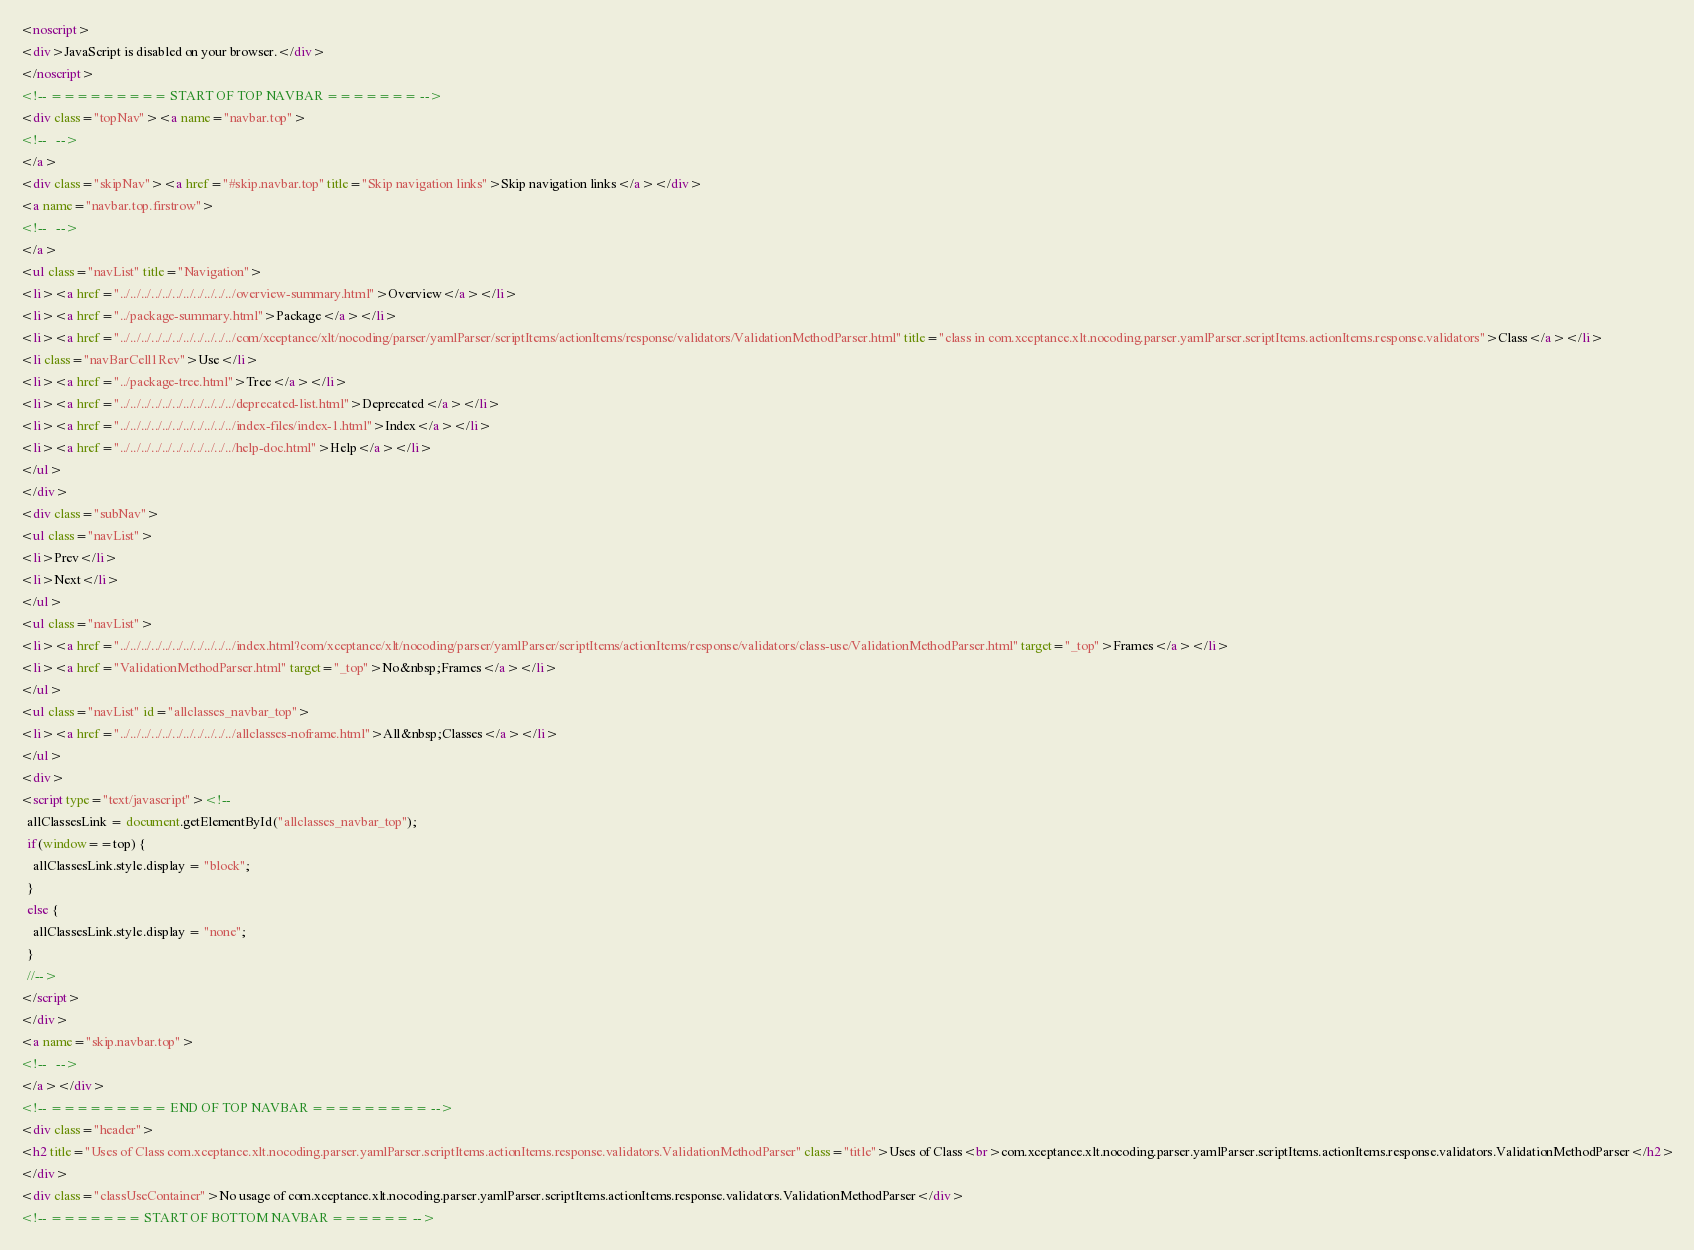Convert code to text. <code><loc_0><loc_0><loc_500><loc_500><_HTML_><noscript>
<div>JavaScript is disabled on your browser.</div>
</noscript>
<!-- ========= START OF TOP NAVBAR ======= -->
<div class="topNav"><a name="navbar.top">
<!--   -->
</a>
<div class="skipNav"><a href="#skip.navbar.top" title="Skip navigation links">Skip navigation links</a></div>
<a name="navbar.top.firstrow">
<!--   -->
</a>
<ul class="navList" title="Navigation">
<li><a href="../../../../../../../../../../../overview-summary.html">Overview</a></li>
<li><a href="../package-summary.html">Package</a></li>
<li><a href="../../../../../../../../../../../com/xceptance/xlt/nocoding/parser/yamlParser/scriptItems/actionItems/response/validators/ValidationMethodParser.html" title="class in com.xceptance.xlt.nocoding.parser.yamlParser.scriptItems.actionItems.response.validators">Class</a></li>
<li class="navBarCell1Rev">Use</li>
<li><a href="../package-tree.html">Tree</a></li>
<li><a href="../../../../../../../../../../../deprecated-list.html">Deprecated</a></li>
<li><a href="../../../../../../../../../../../index-files/index-1.html">Index</a></li>
<li><a href="../../../../../../../../../../../help-doc.html">Help</a></li>
</ul>
</div>
<div class="subNav">
<ul class="navList">
<li>Prev</li>
<li>Next</li>
</ul>
<ul class="navList">
<li><a href="../../../../../../../../../../../index.html?com/xceptance/xlt/nocoding/parser/yamlParser/scriptItems/actionItems/response/validators/class-use/ValidationMethodParser.html" target="_top">Frames</a></li>
<li><a href="ValidationMethodParser.html" target="_top">No&nbsp;Frames</a></li>
</ul>
<ul class="navList" id="allclasses_navbar_top">
<li><a href="../../../../../../../../../../../allclasses-noframe.html">All&nbsp;Classes</a></li>
</ul>
<div>
<script type="text/javascript"><!--
  allClassesLink = document.getElementById("allclasses_navbar_top");
  if(window==top) {
    allClassesLink.style.display = "block";
  }
  else {
    allClassesLink.style.display = "none";
  }
  //-->
</script>
</div>
<a name="skip.navbar.top">
<!--   -->
</a></div>
<!-- ========= END OF TOP NAVBAR ========= -->
<div class="header">
<h2 title="Uses of Class com.xceptance.xlt.nocoding.parser.yamlParser.scriptItems.actionItems.response.validators.ValidationMethodParser" class="title">Uses of Class<br>com.xceptance.xlt.nocoding.parser.yamlParser.scriptItems.actionItems.response.validators.ValidationMethodParser</h2>
</div>
<div class="classUseContainer">No usage of com.xceptance.xlt.nocoding.parser.yamlParser.scriptItems.actionItems.response.validators.ValidationMethodParser</div>
<!-- ======= START OF BOTTOM NAVBAR ====== --></code> 